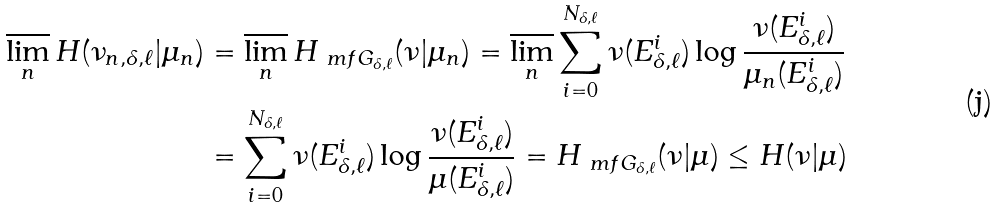<formula> <loc_0><loc_0><loc_500><loc_500>\varlimsup _ { n } H ( \nu _ { n , \delta , \ell } | \mu _ { n } ) & = \varlimsup _ { n } H _ { \ m f G _ { \delta , \ell } } ( \nu | \mu _ { n } ) = \varlimsup _ { n } \sum _ { i = 0 } ^ { N _ { \delta , \ell } } \nu ( E ^ { i } _ { \delta , \ell } ) \log \frac { \nu ( E ^ { i } _ { \delta , \ell } ) } { \mu _ { n } ( E ^ { i } _ { \delta , \ell } ) } \\ & = \sum _ { i = 0 } ^ { N _ { \delta , \ell } } \nu ( E ^ { i } _ { \delta , \ell } ) \log \frac { \nu ( E ^ { i } _ { \delta , \ell } ) } { \mu ( E ^ { i } _ { \delta , \ell } ) } = H _ { \ m f G _ { \delta , \ell } } ( \nu | \mu ) \leq H ( \nu | \mu )</formula> 